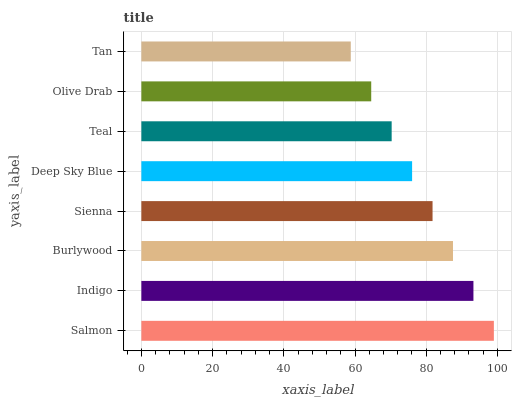Is Tan the minimum?
Answer yes or no. Yes. Is Salmon the maximum?
Answer yes or no. Yes. Is Indigo the minimum?
Answer yes or no. No. Is Indigo the maximum?
Answer yes or no. No. Is Salmon greater than Indigo?
Answer yes or no. Yes. Is Indigo less than Salmon?
Answer yes or no. Yes. Is Indigo greater than Salmon?
Answer yes or no. No. Is Salmon less than Indigo?
Answer yes or no. No. Is Sienna the high median?
Answer yes or no. Yes. Is Deep Sky Blue the low median?
Answer yes or no. Yes. Is Olive Drab the high median?
Answer yes or no. No. Is Indigo the low median?
Answer yes or no. No. 